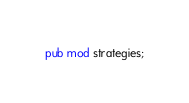<code> <loc_0><loc_0><loc_500><loc_500><_Rust_>pub mod strategies;
</code> 